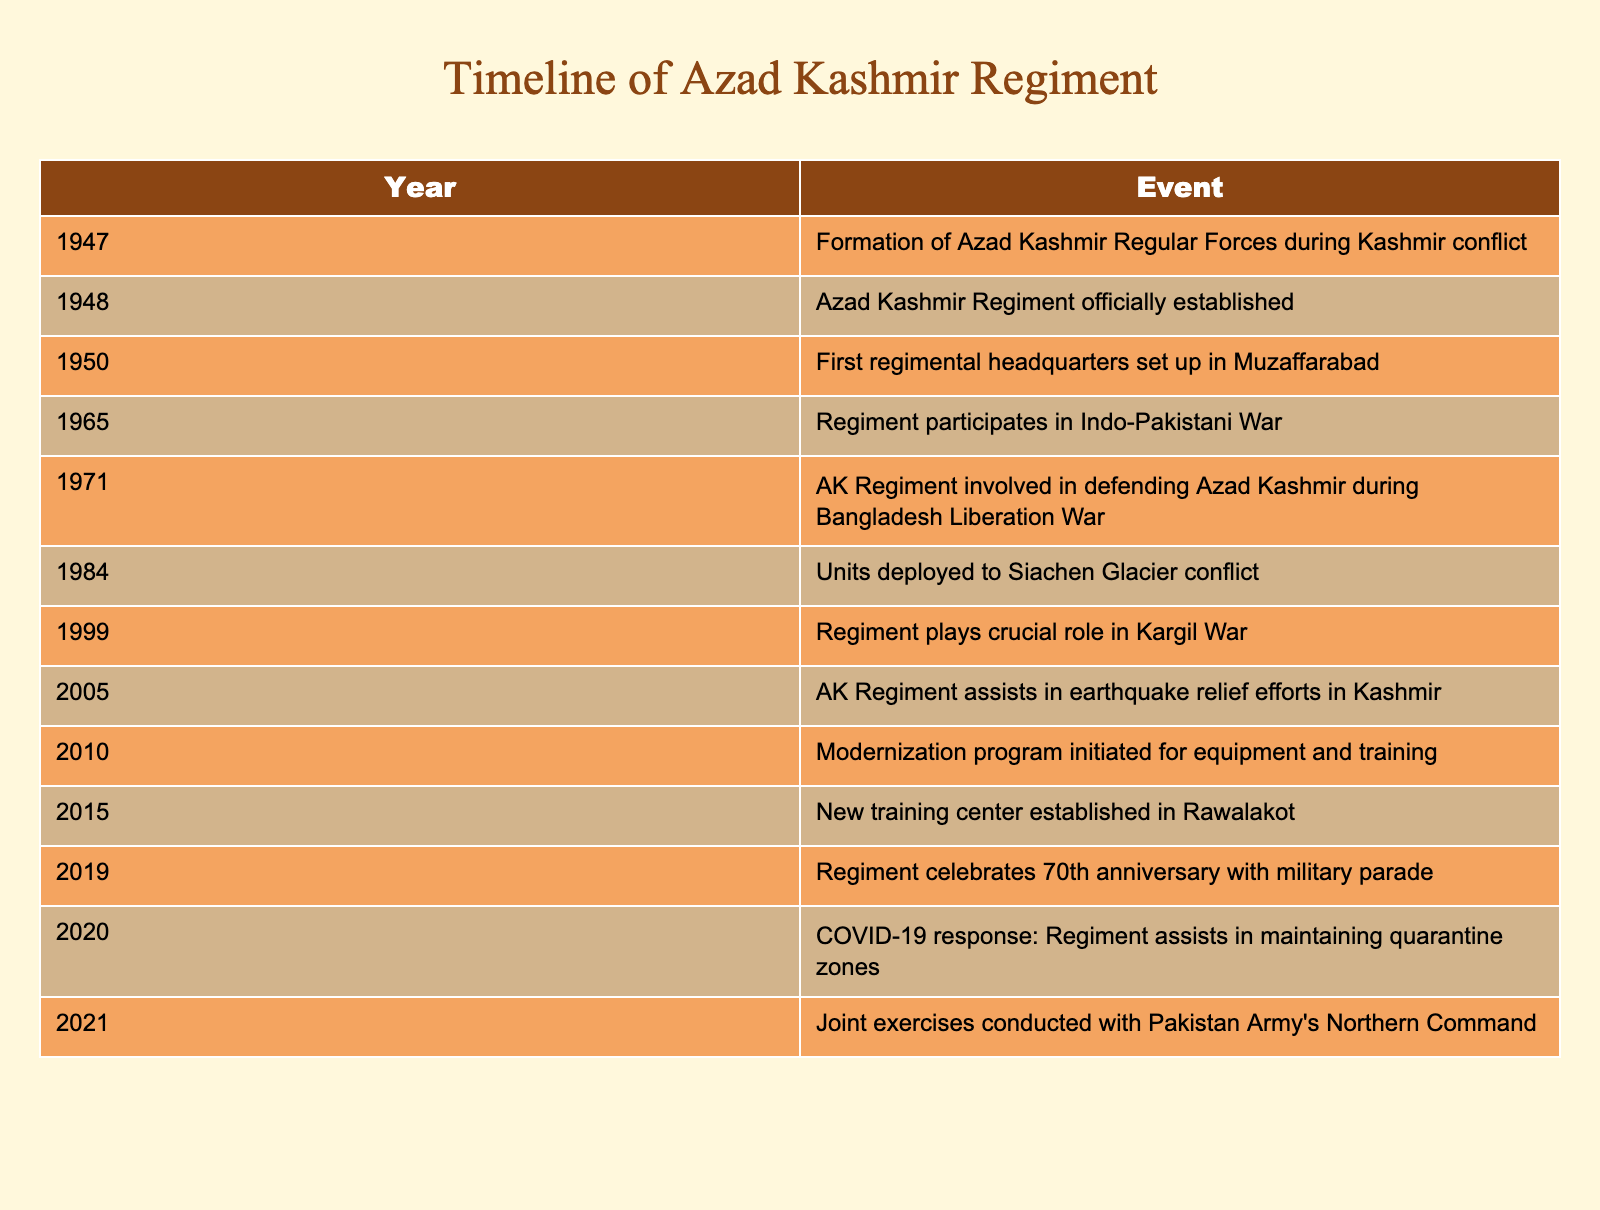What year was the Azad Kashmir Regiment officially established? The table lists the events and their corresponding years. Looking at the event "Azad Kashmir Regiment officially established," we find that the year is 1948.
Answer: 1948 In which year did the Azad Kashmir Regiment participate in the Indo-Pakistani War? Referring to the table, the event related to the Indo-Pakistani War is listed as occurring in 1965.
Answer: 1965 How many significant events are listed for the year 2005? The table shows one event for the year 2005, which is "AK Regiment assists in earthquake relief efforts in Kashmir." Therefore, the count of significant events in that year is 1.
Answer: 1 True or False: The Azad Kashmir Regiment has been involved in conflicts at the Siachen Glacier. The table includes an event from 1984 stating "Units deployed to Siachen Glacier conflict," confirming that this is true.
Answer: True What is the time span from the formation of the Azad Kashmir Regular Forces to the establishment of the regiment? The relevant events show the formation of the Azad Kashmir Regular Forces in 1947 and the official establishment of the Azad Kashmir Regiment in 1948. Thus, the time span is 1948 - 1947 = 1 year.
Answer: 1 year Which year marks the 70th anniversary celebration of the Azad Kashmir Regiment? The table states that the 70th anniversary was celebrated in 2019, according to the event listed.
Answer: 2019 How many times did the Azad Kashmir Regiment assist in non-combat operations based on the table? The table lists two non-combat operations: in 2005 for earthquake relief efforts and in 2020 for COVID-19 response. This totals to 2 non-combat operations.
Answer: 2 What was the last listed event concerning the Azad Kashmir Regiment as of 2021? Referring to the last event in the table, it mentions "Joint exercises conducted with Pakistan Army's Northern Command" as the most recent event.
Answer: Joint exercises with Pakistan Army How many years apart are the establishment of the new training center and the modernization program? The new training center was established in 2015 and the modernization program initiated in 2010. Thus, calculating the difference: 2015 - 2010 = 5 years.
Answer: 5 years In what year did the Azad Kashmir Regiment aid in maintaining quarantine zones during the COVID-19 pandemic? According to the table, the Regiment assisted in maintaining quarantine zones in the year 2020, as indicated in the respective event.
Answer: 2020 